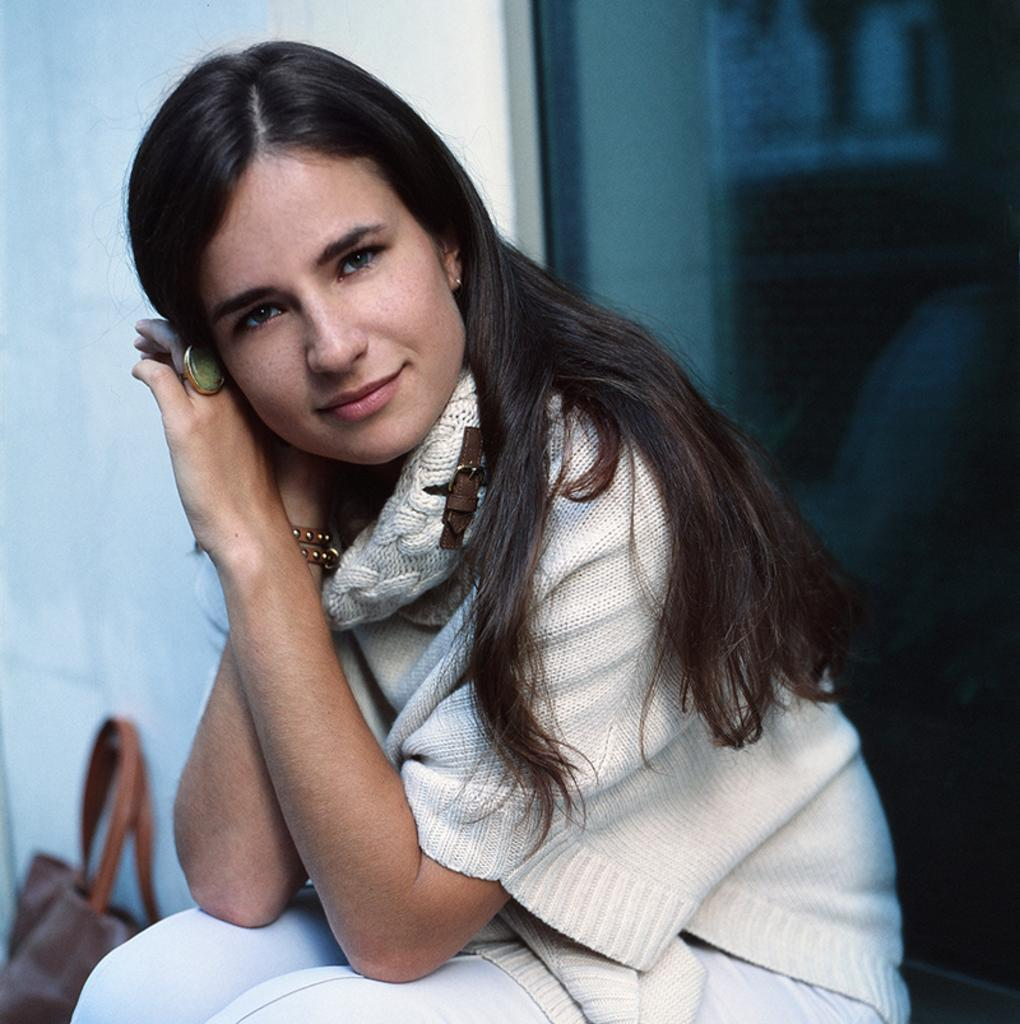What is the woman doing in the image? The woman is sitting in the image. What object can be seen near the woman? There is a bag visible in the image. What level of expertise does the woman have with cork in the image? There is no mention of cork or any indication of the woman's expertise in the image. 